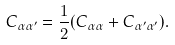Convert formula to latex. <formula><loc_0><loc_0><loc_500><loc_500>C _ { \alpha \alpha ^ { \prime } } = \frac { 1 } { 2 } ( C _ { \alpha \alpha } + C _ { \alpha ^ { \prime } \alpha ^ { \prime } } ) .</formula> 